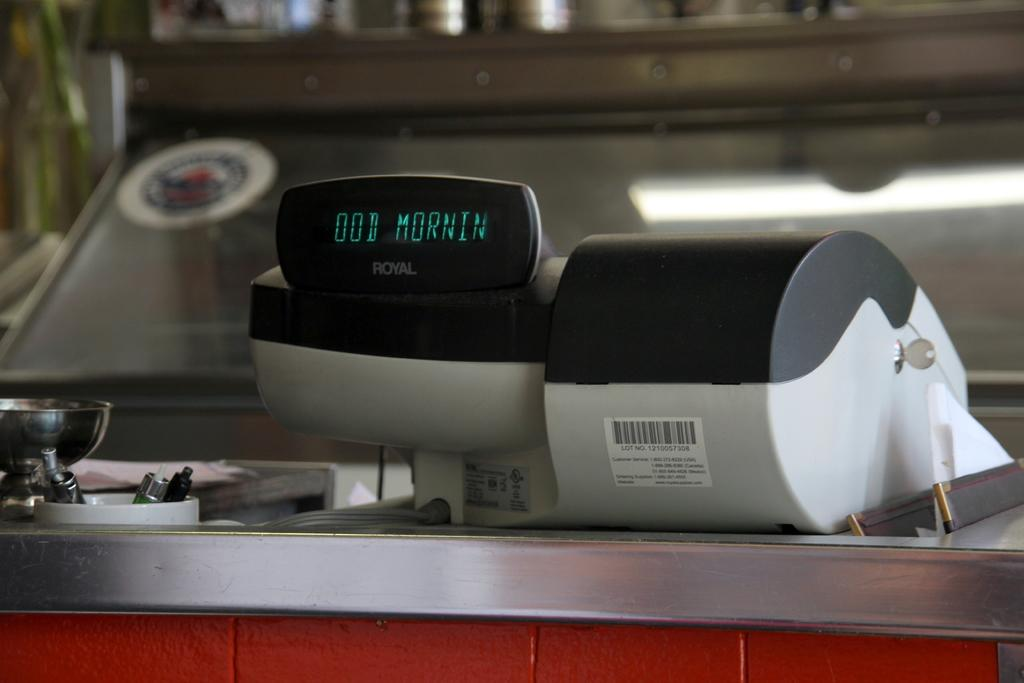<image>
Present a compact description of the photo's key features. Good Morning is displayed on a Royal cash register. 